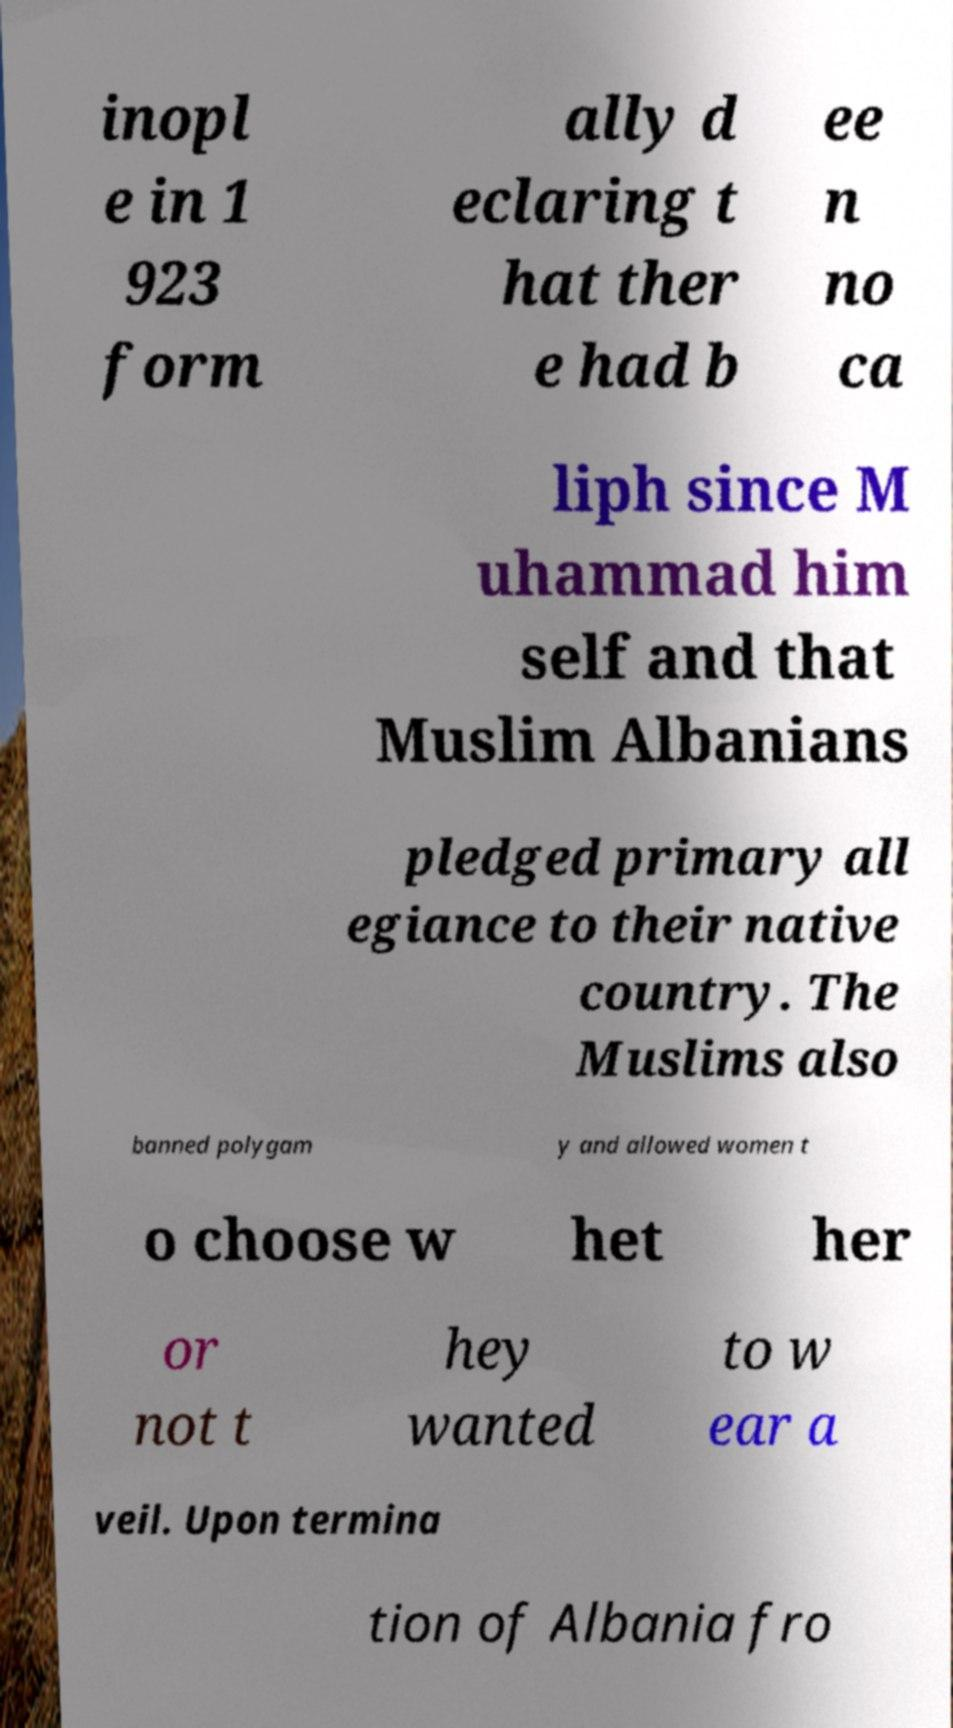Can you read and provide the text displayed in the image?This photo seems to have some interesting text. Can you extract and type it out for me? inopl e in 1 923 form ally d eclaring t hat ther e had b ee n no ca liph since M uhammad him self and that Muslim Albanians pledged primary all egiance to their native country. The Muslims also banned polygam y and allowed women t o choose w het her or not t hey wanted to w ear a veil. Upon termina tion of Albania fro 